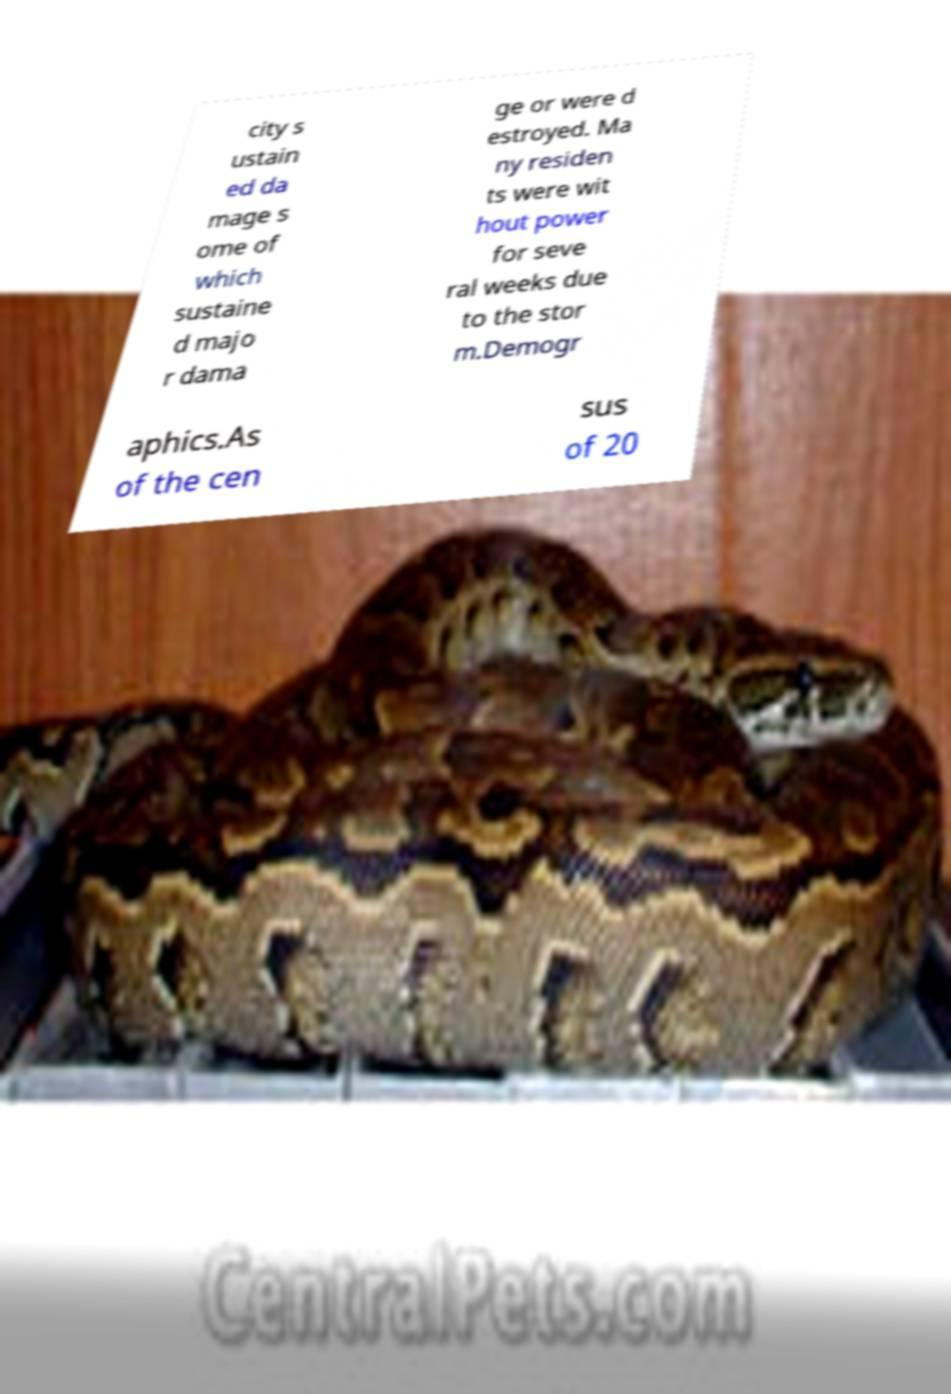I need the written content from this picture converted into text. Can you do that? city s ustain ed da mage s ome of which sustaine d majo r dama ge or were d estroyed. Ma ny residen ts were wit hout power for seve ral weeks due to the stor m.Demogr aphics.As of the cen sus of 20 